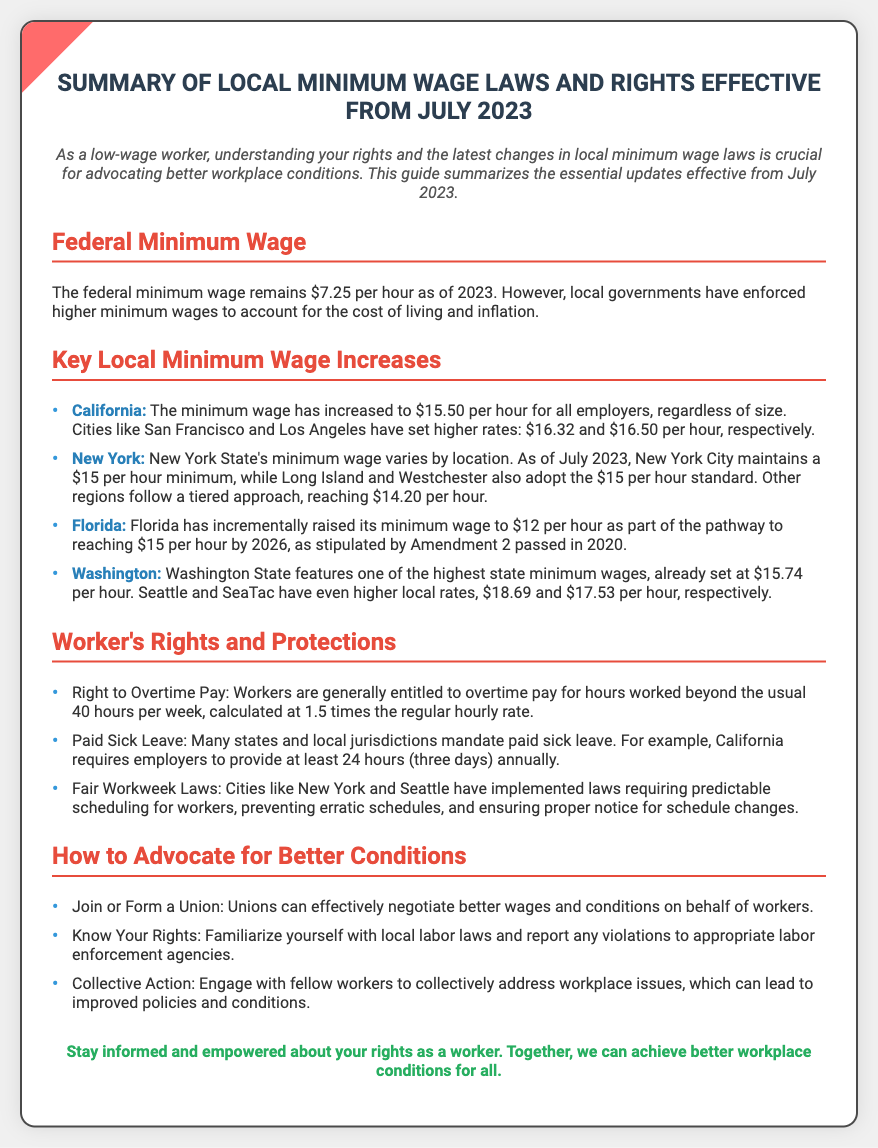What is the federal minimum wage as of 2023? The federal minimum wage remains $7.25 per hour as of 2023.
Answer: $7.25 What is California's minimum wage effective July 2023? The minimum wage in California has increased to $15.50 per hour for all employers.
Answer: $15.50 What is the minimum wage in New York City? New York City maintains a $15 per hour minimum wage.
Answer: $15 What is Florida's minimum wage as part of the pathway to $15? Florida has incrementally raised its minimum wage to $12 per hour.
Answer: $12 What is the overtime pay rate for workers? Workers are generally entitled to overtime pay calculated at 1.5 times the regular hourly rate.
Answer: 1.5 times What is a requirement of Fair Workweek Laws? Cities like New York and Seattle have implemented laws requiring predictable scheduling for workers.
Answer: Predictable scheduling How can workers advocate for better conditions? One way to advocate for better conditions is to join or form a union.
Answer: Join or form a union What is mandated in California for paid sick leave? California requires employers to provide at least 24 hours (three days) annually.
Answer: 24 hours (three days) What is one example of a local minimum wage higher than the state wage? San Francisco has set a higher rate of $16.32 per hour.
Answer: $16.32 